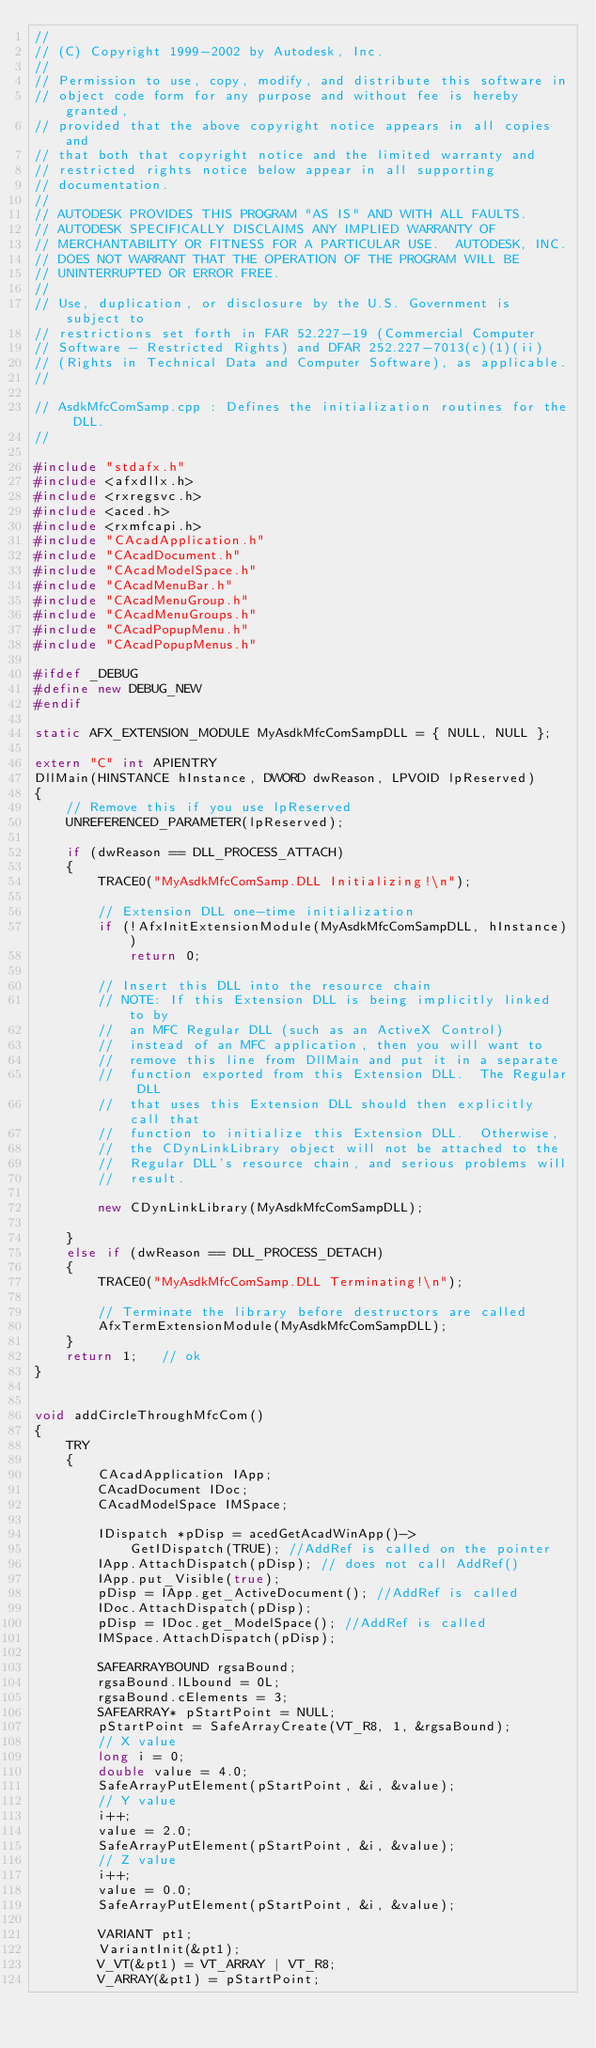Convert code to text. <code><loc_0><loc_0><loc_500><loc_500><_C++_>//
// (C) Copyright 1999-2002 by Autodesk, Inc. 
//
// Permission to use, copy, modify, and distribute this software in
// object code form for any purpose and without fee is hereby granted,
// provided that the above copyright notice appears in all copies and
// that both that copyright notice and the limited warranty and
// restricted rights notice below appear in all supporting
// documentation.
//
// AUTODESK PROVIDES THIS PROGRAM "AS IS" AND WITH ALL FAULTS.
// AUTODESK SPECIFICALLY DISCLAIMS ANY IMPLIED WARRANTY OF
// MERCHANTABILITY OR FITNESS FOR A PARTICULAR USE.  AUTODESK, INC.
// DOES NOT WARRANT THAT THE OPERATION OF THE PROGRAM WILL BE
// UNINTERRUPTED OR ERROR FREE.
//
// Use, duplication, or disclosure by the U.S. Government is subject to
// restrictions set forth in FAR 52.227-19 (Commercial Computer
// Software - Restricted Rights) and DFAR 252.227-7013(c)(1)(ii)
// (Rights in Technical Data and Computer Software), as applicable.
//

// AsdkMfcComSamp.cpp : Defines the initialization routines for the DLL.
//

#include "stdafx.h"
#include <afxdllx.h>
#include <rxregsvc.h>
#include <aced.h>
#include <rxmfcapi.h>
#include "CAcadApplication.h"
#include "CAcadDocument.h"
#include "CAcadModelSpace.h"
#include "CAcadMenuBar.h"
#include "CAcadMenuGroup.h"
#include "CAcadMenuGroups.h"
#include "CAcadPopupMenu.h"
#include "CAcadPopupMenus.h"

#ifdef _DEBUG
#define new DEBUG_NEW
#endif

static AFX_EXTENSION_MODULE MyAsdkMfcComSampDLL = { NULL, NULL };

extern "C" int APIENTRY
DllMain(HINSTANCE hInstance, DWORD dwReason, LPVOID lpReserved)
{
	// Remove this if you use lpReserved
	UNREFERENCED_PARAMETER(lpReserved);

	if (dwReason == DLL_PROCESS_ATTACH)
	{
		TRACE0("MyAsdkMfcComSamp.DLL Initializing!\n");
		
		// Extension DLL one-time initialization
		if (!AfxInitExtensionModule(MyAsdkMfcComSampDLL, hInstance))
			return 0;

		// Insert this DLL into the resource chain
		// NOTE: If this Extension DLL is being implicitly linked to by
		//  an MFC Regular DLL (such as an ActiveX Control)
		//  instead of an MFC application, then you will want to
		//  remove this line from DllMain and put it in a separate
		//  function exported from this Extension DLL.  The Regular DLL
		//  that uses this Extension DLL should then explicitly call that
		//  function to initialize this Extension DLL.  Otherwise,
		//  the CDynLinkLibrary object will not be attached to the
		//  Regular DLL's resource chain, and serious problems will
		//  result.

		new CDynLinkLibrary(MyAsdkMfcComSampDLL);

	}
	else if (dwReason == DLL_PROCESS_DETACH)
	{
		TRACE0("MyAsdkMfcComSamp.DLL Terminating!\n");

		// Terminate the library before destructors are called
		AfxTermExtensionModule(MyAsdkMfcComSampDLL);
	}
	return 1;   // ok
}


void addCircleThroughMfcCom()
{
	TRY
	{
		CAcadApplication IApp;
		CAcadDocument IDoc;
		CAcadModelSpace IMSpace;

		IDispatch *pDisp = acedGetAcadWinApp()->
			GetIDispatch(TRUE); //AddRef is called on the pointer
		IApp.AttachDispatch(pDisp); // does not call AddRef()
		IApp.put_Visible(true);
		pDisp = IApp.get_ActiveDocument(); //AddRef is called
		IDoc.AttachDispatch(pDisp);
		pDisp = IDoc.get_ModelSpace(); //AddRef is called
		IMSpace.AttachDispatch(pDisp);

		SAFEARRAYBOUND rgsaBound;
		rgsaBound.lLbound = 0L;
		rgsaBound.cElements = 3;
		SAFEARRAY* pStartPoint = NULL;
		pStartPoint = SafeArrayCreate(VT_R8, 1, &rgsaBound);
		// X value
		long i = 0;
		double value = 4.0;
		SafeArrayPutElement(pStartPoint, &i, &value);
		// Y value
		i++;
		value = 2.0;
		SafeArrayPutElement(pStartPoint, &i, &value);
		// Z value
		i++;
		value = 0.0;
		SafeArrayPutElement(pStartPoint, &i, &value);

		VARIANT pt1;
		VariantInit(&pt1);
		V_VT(&pt1) = VT_ARRAY | VT_R8;
		V_ARRAY(&pt1) = pStartPoint;</code> 